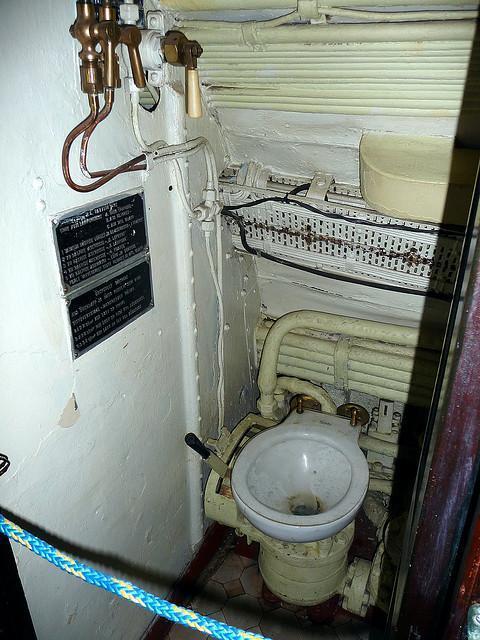How many laptops are on the table?
Give a very brief answer. 0. 